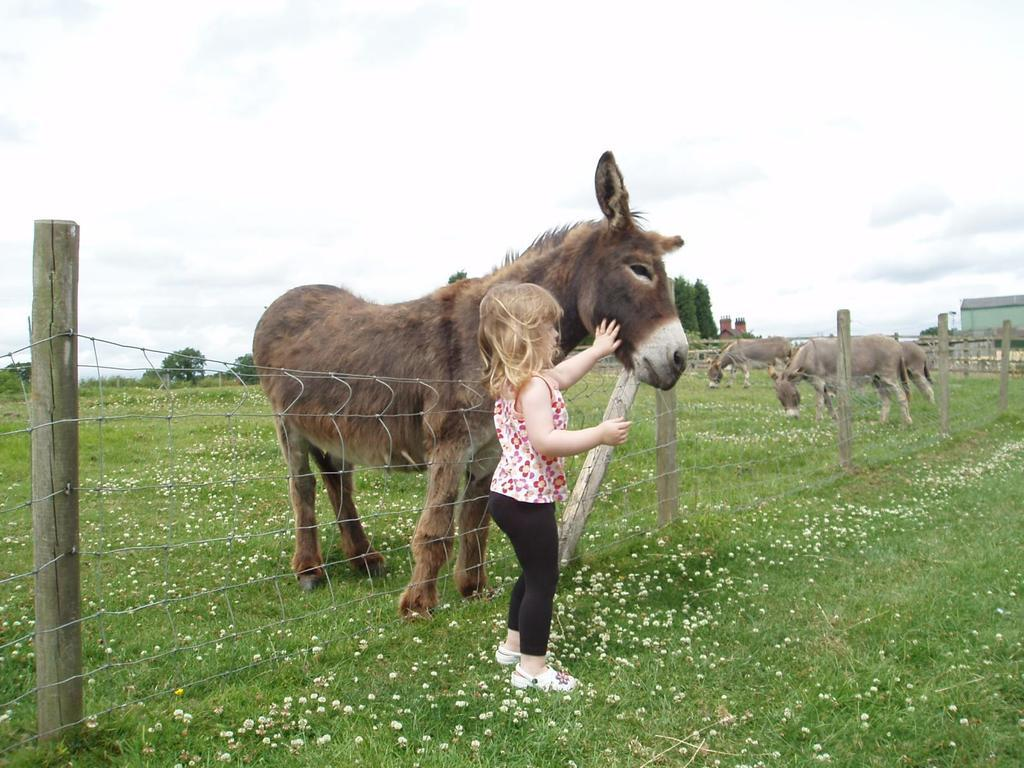What is the main subject in the center of the image? There is a kid in the center of the image. What animals can be seen in the image? There are donkeys in the image. What type of vegetation is present in the image? Grass is present in the image, along with flowers. What structures can be seen in the image? Poles and fences are visible in the image. What can be seen in the background of the image? The sky, clouds, trees, and buildings are visible in the background of the image. How many bears are visible in the image? There are no bears present in the image. What type of smile does the kid have in the image? The provided facts do not mention the kid's facial expression, so we cannot determine if they are smiling or not. 